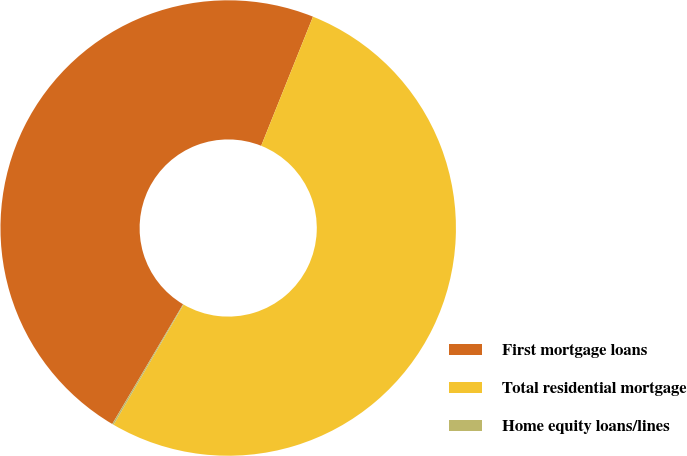<chart> <loc_0><loc_0><loc_500><loc_500><pie_chart><fcel>First mortgage loans<fcel>Total residential mortgage<fcel>Home equity loans/lines<nl><fcel>47.57%<fcel>52.32%<fcel>0.11%<nl></chart> 